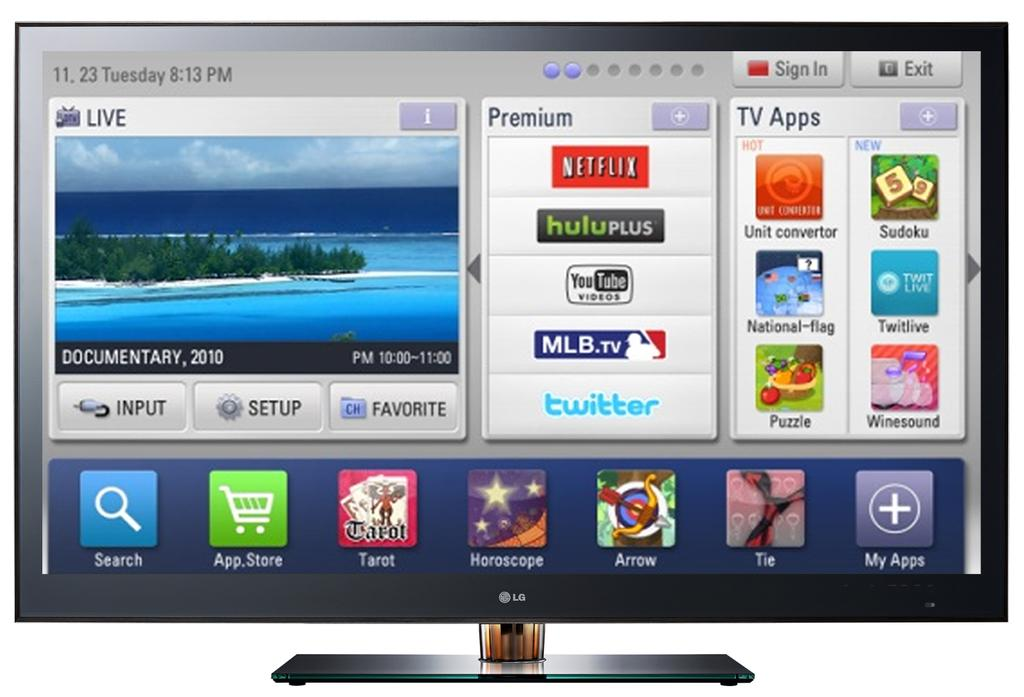<image>
Render a clear and concise summary of the photo. a Netflix logo that is on the television 